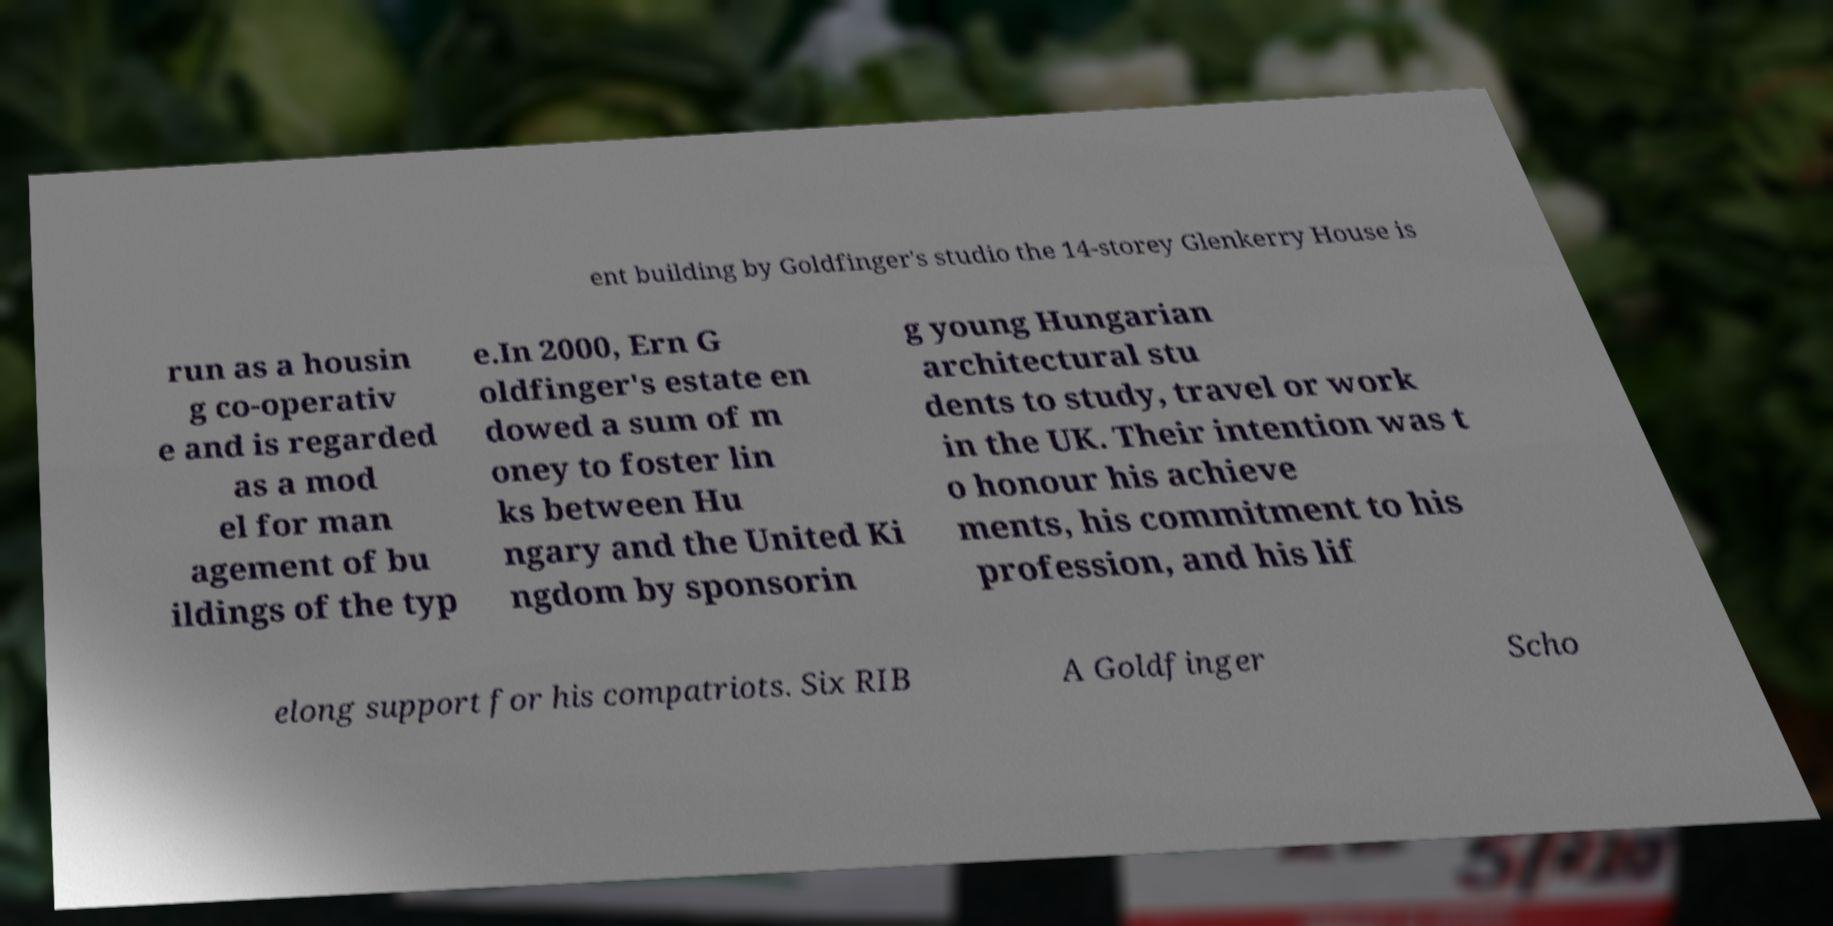Can you accurately transcribe the text from the provided image for me? ent building by Goldfinger's studio the 14-storey Glenkerry House is run as a housin g co-operativ e and is regarded as a mod el for man agement of bu ildings of the typ e.In 2000, Ern G oldfinger's estate en dowed a sum of m oney to foster lin ks between Hu ngary and the United Ki ngdom by sponsorin g young Hungarian architectural stu dents to study, travel or work in the UK. Their intention was t o honour his achieve ments, his commitment to his profession, and his lif elong support for his compatriots. Six RIB A Goldfinger Scho 